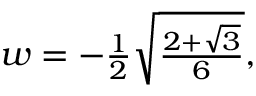Convert formula to latex. <formula><loc_0><loc_0><loc_500><loc_500>\begin{array} { r } { w = - \frac { 1 } { 2 } \sqrt { \frac { 2 + \sqrt { 3 } } { 6 } } , } \end{array}</formula> 